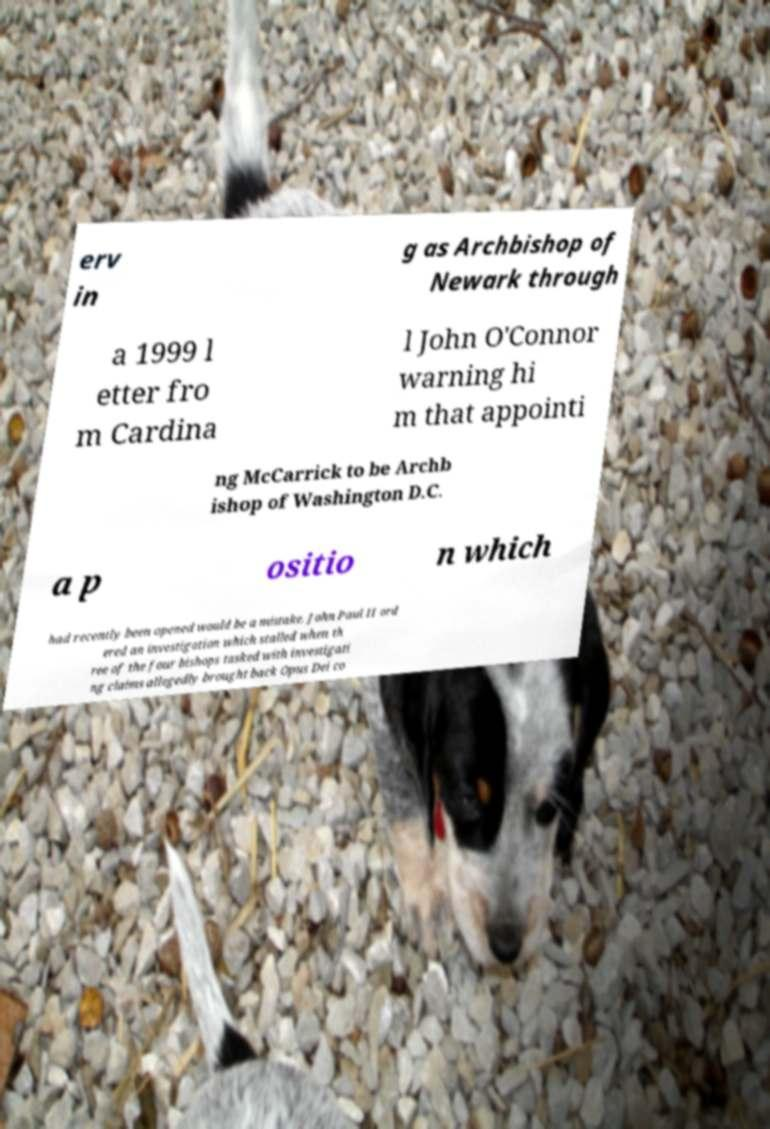I need the written content from this picture converted into text. Can you do that? erv in g as Archbishop of Newark through a 1999 l etter fro m Cardina l John O'Connor warning hi m that appointi ng McCarrick to be Archb ishop of Washington D.C. a p ositio n which had recently been opened would be a mistake. John Paul II ord ered an investigation which stalled when th ree of the four bishops tasked with investigati ng claims allegedly brought back Opus Dei co 